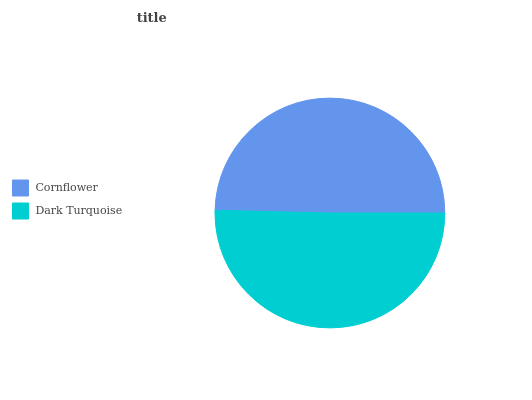Is Cornflower the minimum?
Answer yes or no. Yes. Is Dark Turquoise the maximum?
Answer yes or no. Yes. Is Dark Turquoise the minimum?
Answer yes or no. No. Is Dark Turquoise greater than Cornflower?
Answer yes or no. Yes. Is Cornflower less than Dark Turquoise?
Answer yes or no. Yes. Is Cornflower greater than Dark Turquoise?
Answer yes or no. No. Is Dark Turquoise less than Cornflower?
Answer yes or no. No. Is Dark Turquoise the high median?
Answer yes or no. Yes. Is Cornflower the low median?
Answer yes or no. Yes. Is Cornflower the high median?
Answer yes or no. No. Is Dark Turquoise the low median?
Answer yes or no. No. 